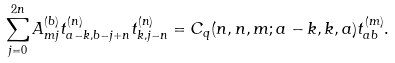<formula> <loc_0><loc_0><loc_500><loc_500>\sum _ { j = 0 } ^ { 2 n } A ^ { ( b ) } _ { m j } t ^ { ( n ) } _ { a - k , b - j + n } t ^ { ( n ) } _ { k , j - n } = C _ { q } ( n , n , m ; a - k , k , a ) t ^ { ( m ) } _ { a b } .</formula> 